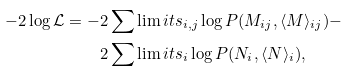<formula> <loc_0><loc_0><loc_500><loc_500>- 2 \log \mathcal { L } = - & 2 \sum \lim i t s _ { i , j } \log P ( M _ { i j } , \langle M \rangle _ { i j } ) - \\ & 2 \sum \lim i t s _ { i } \log P ( N _ { i } , \langle N \rangle _ { i } ) ,</formula> 